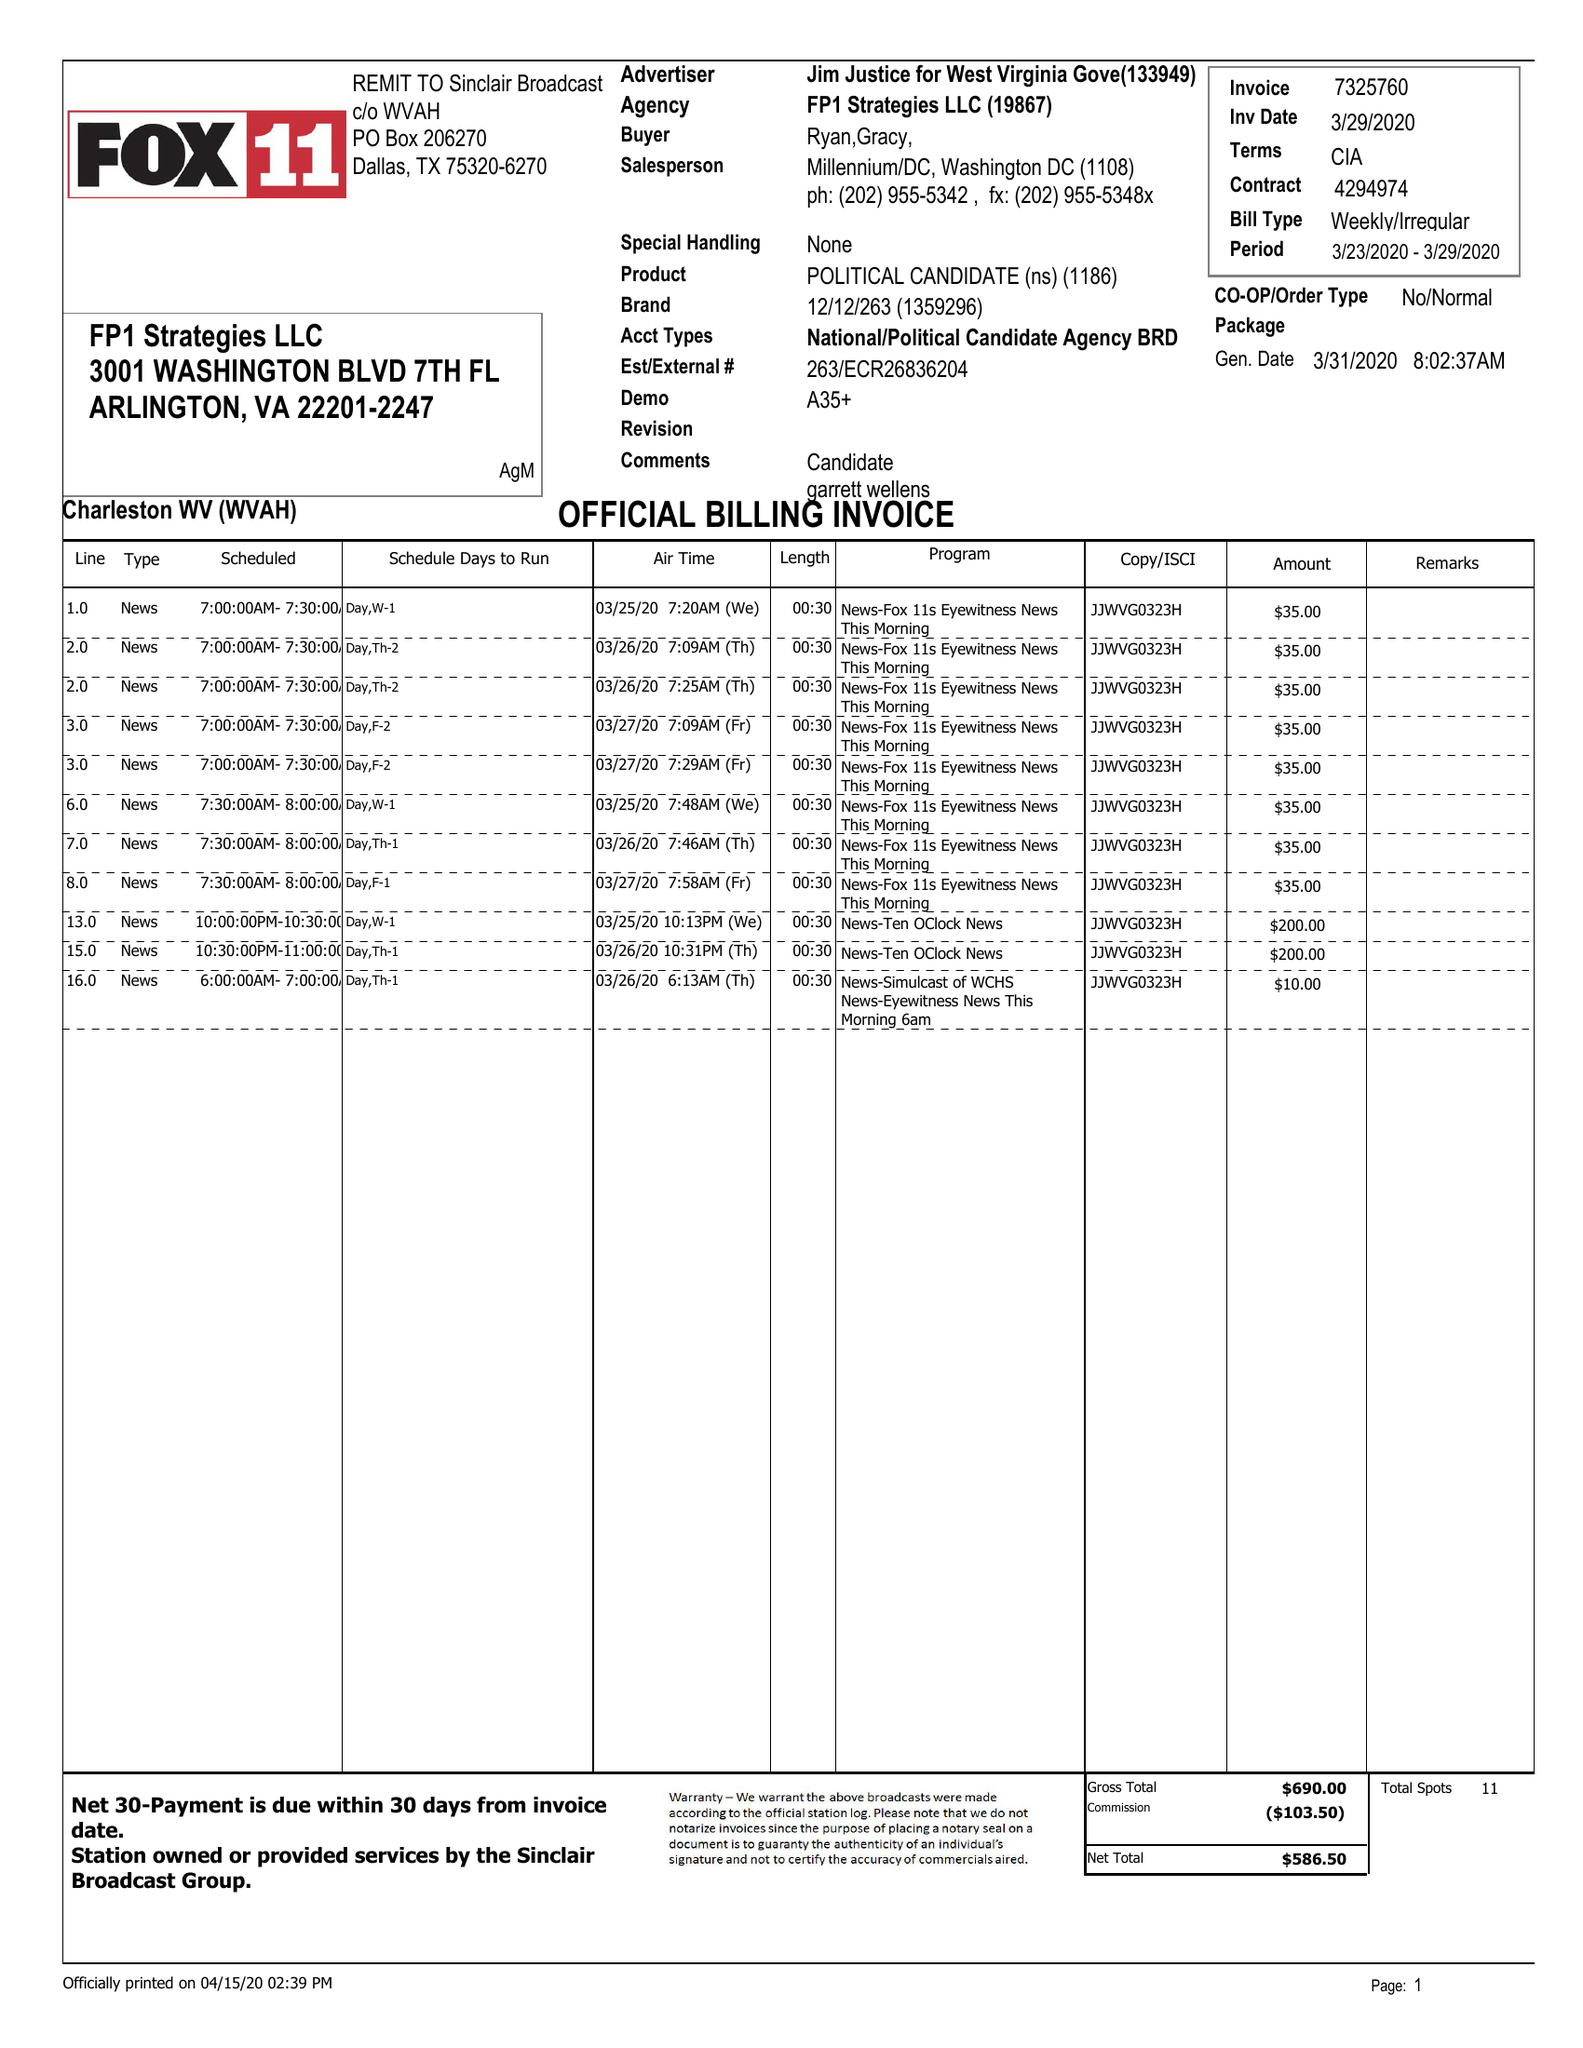What is the value for the advertiser?
Answer the question using a single word or phrase. JIM JUSTICE FOR WEST VIRGINIA GOVE 